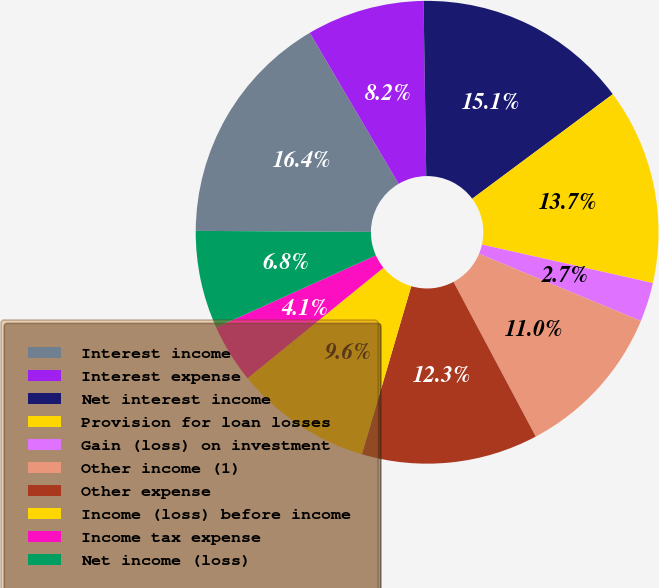<chart> <loc_0><loc_0><loc_500><loc_500><pie_chart><fcel>Interest income<fcel>Interest expense<fcel>Net interest income<fcel>Provision for loan losses<fcel>Gain (loss) on investment<fcel>Other income (1)<fcel>Other expense<fcel>Income (loss) before income<fcel>Income tax expense<fcel>Net income (loss)<nl><fcel>16.44%<fcel>8.22%<fcel>15.07%<fcel>13.7%<fcel>2.74%<fcel>10.96%<fcel>12.33%<fcel>9.59%<fcel>4.11%<fcel>6.85%<nl></chart> 